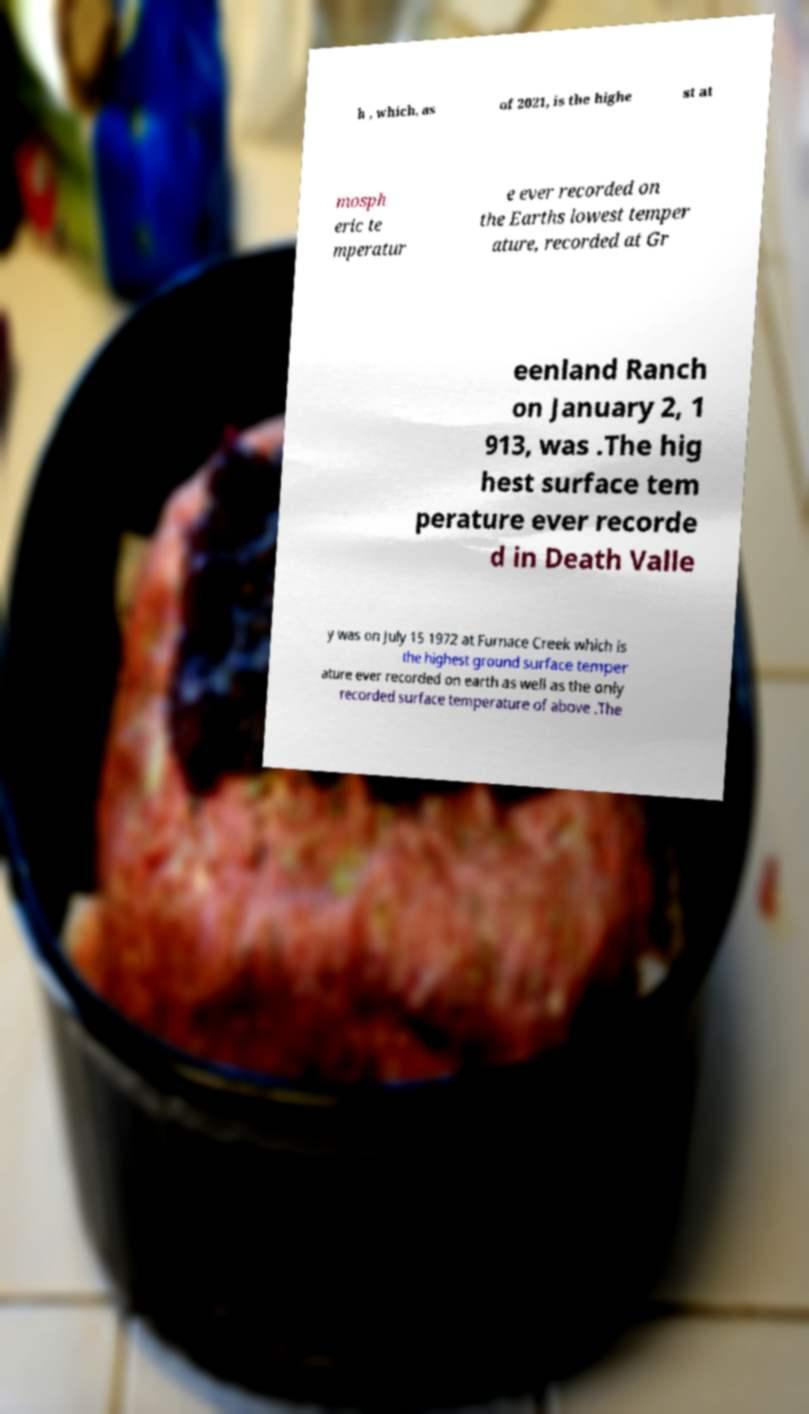Can you read and provide the text displayed in the image?This photo seems to have some interesting text. Can you extract and type it out for me? h , which, as of 2021, is the highe st at mosph eric te mperatur e ever recorded on the Earths lowest temper ature, recorded at Gr eenland Ranch on January 2, 1 913, was .The hig hest surface tem perature ever recorde d in Death Valle y was on July 15 1972 at Furnace Creek which is the highest ground surface temper ature ever recorded on earth as well as the only recorded surface temperature of above .The 